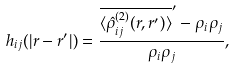Convert formula to latex. <formula><loc_0><loc_0><loc_500><loc_500>h _ { i j } ( | r - r ^ { \prime } | ) = \frac { \overline { \langle \hat { \rho } ^ { ( 2 ) } _ { i j } ( r , r ^ { \prime } ) \rangle } ^ { \prime } - \rho _ { i } \rho _ { j } } { \rho _ { i } \rho _ { j } } ,</formula> 